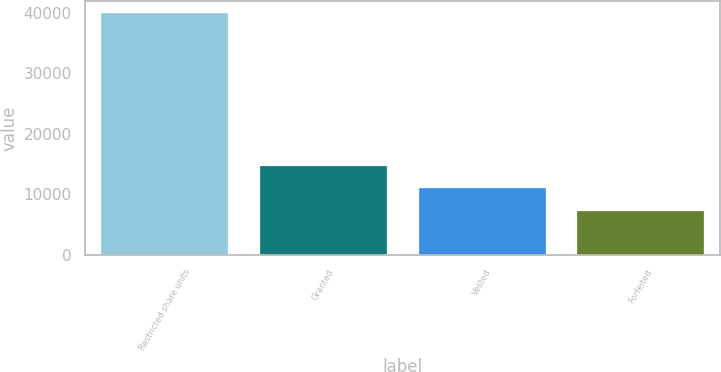<chart> <loc_0><loc_0><loc_500><loc_500><bar_chart><fcel>Restricted share units<fcel>Granted<fcel>Vested<fcel>Forfeited<nl><fcel>39896<fcel>14676<fcel>10971.5<fcel>7267<nl></chart> 